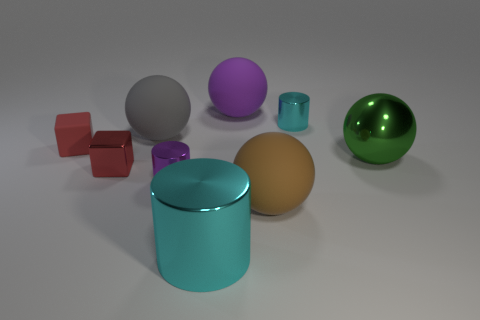Subtract all cyan spheres. Subtract all blue cubes. How many spheres are left? 4 Add 1 red metal blocks. How many objects exist? 10 Subtract all cylinders. How many objects are left? 6 Subtract 0 gray cubes. How many objects are left? 9 Subtract all green metallic spheres. Subtract all big cyan spheres. How many objects are left? 8 Add 2 large brown things. How many large brown things are left? 3 Add 2 metallic balls. How many metallic balls exist? 3 